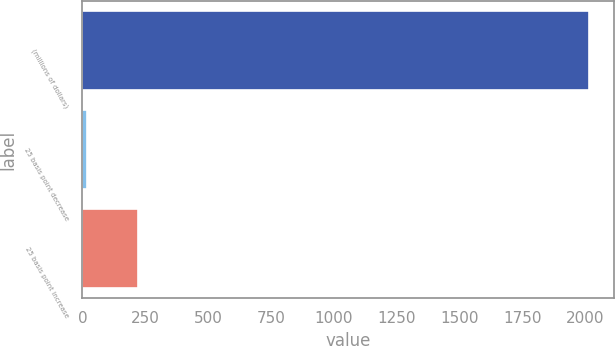Convert chart to OTSL. <chart><loc_0><loc_0><loc_500><loc_500><bar_chart><fcel>(millions of dollars)<fcel>25 basis point decrease<fcel>25 basis point increase<nl><fcel>2015<fcel>20.1<fcel>219.59<nl></chart> 